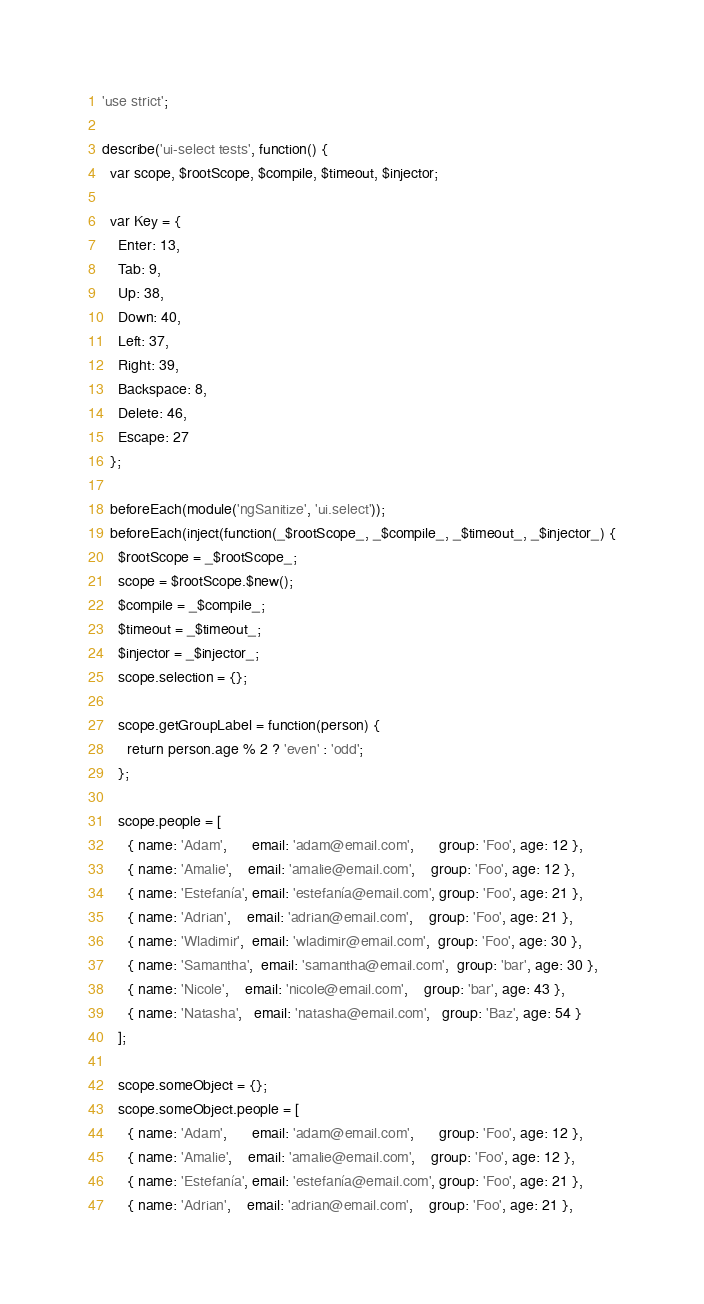<code> <loc_0><loc_0><loc_500><loc_500><_JavaScript_>'use strict';

describe('ui-select tests', function() {
  var scope, $rootScope, $compile, $timeout, $injector;

  var Key = {
    Enter: 13,
    Tab: 9,
    Up: 38,
    Down: 40,
    Left: 37,
    Right: 39,
    Backspace: 8,
    Delete: 46,
    Escape: 27
  };

  beforeEach(module('ngSanitize', 'ui.select'));
  beforeEach(inject(function(_$rootScope_, _$compile_, _$timeout_, _$injector_) {
    $rootScope = _$rootScope_;
    scope = $rootScope.$new();
    $compile = _$compile_;
    $timeout = _$timeout_;
    $injector = _$injector_;
    scope.selection = {};

    scope.getGroupLabel = function(person) {
      return person.age % 2 ? 'even' : 'odd';
    };

    scope.people = [
      { name: 'Adam',      email: 'adam@email.com',      group: 'Foo', age: 12 },
      { name: 'Amalie',    email: 'amalie@email.com',    group: 'Foo', age: 12 },
      { name: 'Estefanía', email: 'estefanía@email.com', group: 'Foo', age: 21 },
      { name: 'Adrian',    email: 'adrian@email.com',    group: 'Foo', age: 21 },
      { name: 'Wladimir',  email: 'wladimir@email.com',  group: 'Foo', age: 30 },
      { name: 'Samantha',  email: 'samantha@email.com',  group: 'bar', age: 30 },
      { name: 'Nicole',    email: 'nicole@email.com',    group: 'bar', age: 43 },
      { name: 'Natasha',   email: 'natasha@email.com',   group: 'Baz', age: 54 }
    ];

    scope.someObject = {};
    scope.someObject.people = [
      { name: 'Adam',      email: 'adam@email.com',      group: 'Foo', age: 12 },
      { name: 'Amalie',    email: 'amalie@email.com',    group: 'Foo', age: 12 },
      { name: 'Estefanía', email: 'estefanía@email.com', group: 'Foo', age: 21 },
      { name: 'Adrian',    email: 'adrian@email.com',    group: 'Foo', age: 21 },</code> 